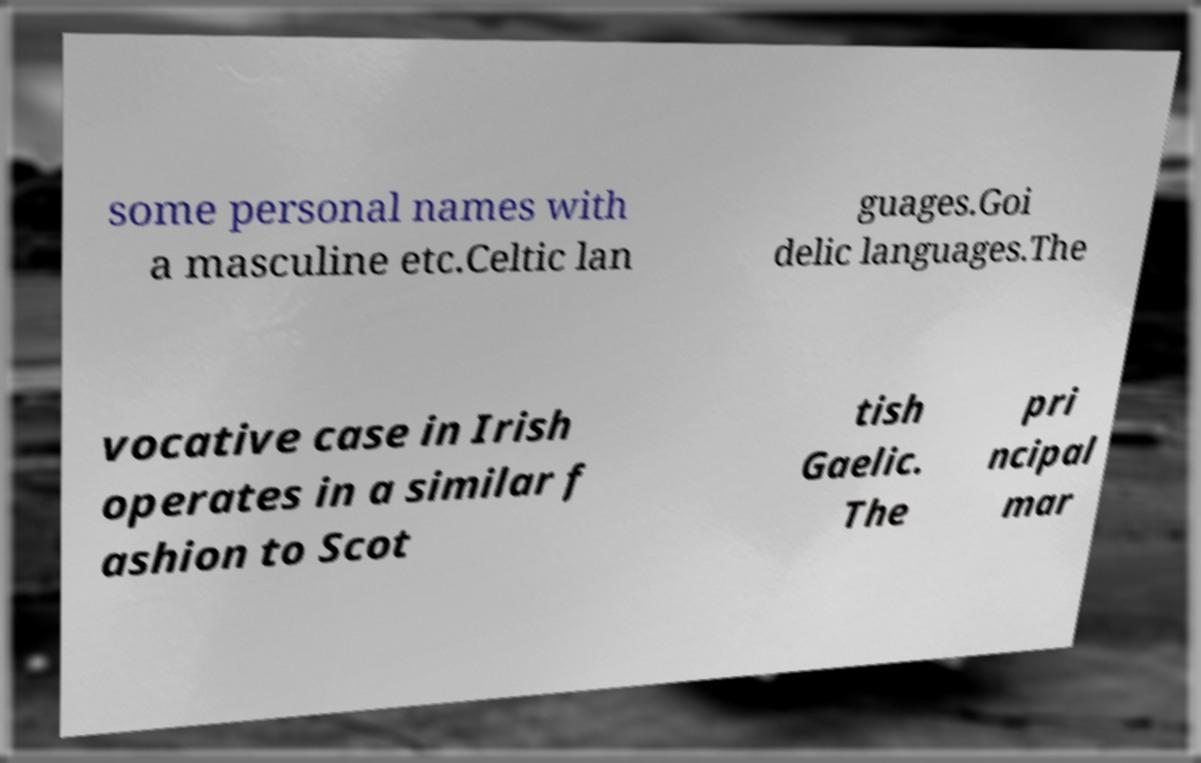What messages or text are displayed in this image? I need them in a readable, typed format. some personal names with a masculine etc.Celtic lan guages.Goi delic languages.The vocative case in Irish operates in a similar f ashion to Scot tish Gaelic. The pri ncipal mar 